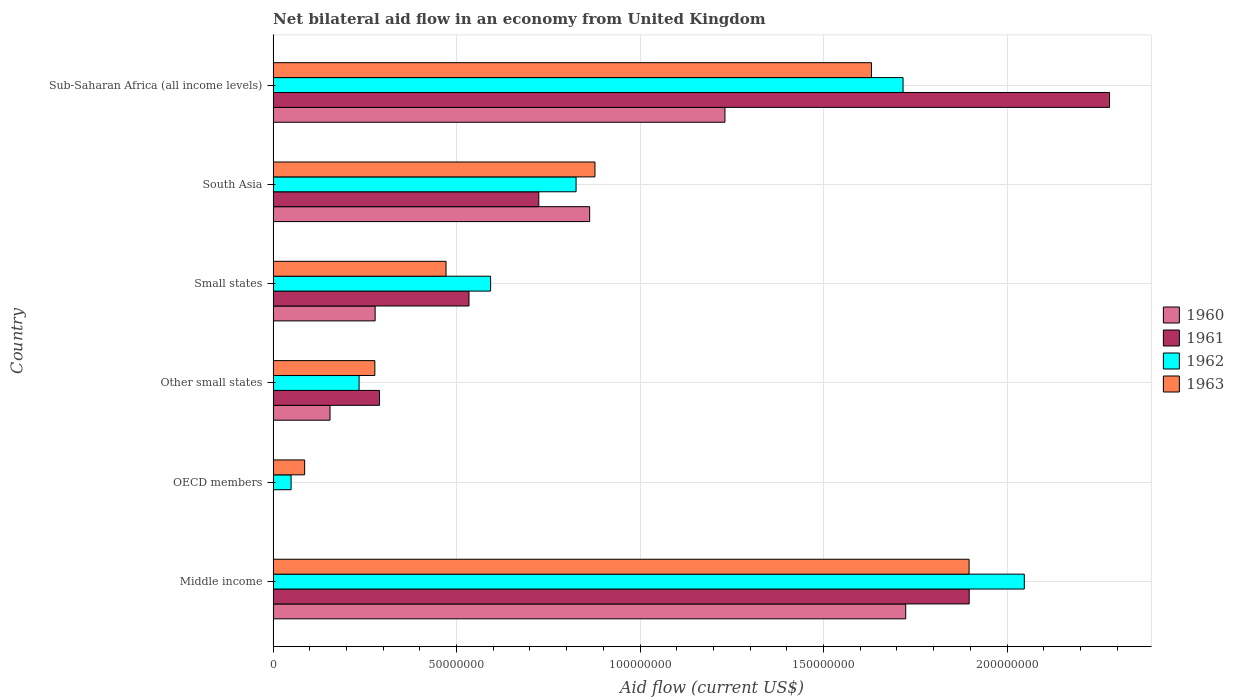How many different coloured bars are there?
Make the answer very short. 4. How many groups of bars are there?
Provide a succinct answer. 6. What is the label of the 3rd group of bars from the top?
Your response must be concise. Small states. What is the net bilateral aid flow in 1963 in Small states?
Provide a succinct answer. 4.71e+07. Across all countries, what is the maximum net bilateral aid flow in 1963?
Offer a very short reply. 1.90e+08. Across all countries, what is the minimum net bilateral aid flow in 1963?
Ensure brevity in your answer.  8.59e+06. In which country was the net bilateral aid flow in 1961 maximum?
Offer a terse response. Sub-Saharan Africa (all income levels). What is the total net bilateral aid flow in 1961 in the graph?
Keep it short and to the point. 5.72e+08. What is the difference between the net bilateral aid flow in 1962 in South Asia and that in Sub-Saharan Africa (all income levels)?
Make the answer very short. -8.91e+07. What is the difference between the net bilateral aid flow in 1963 in South Asia and the net bilateral aid flow in 1961 in Middle income?
Your response must be concise. -1.02e+08. What is the average net bilateral aid flow in 1961 per country?
Your answer should be very brief. 9.54e+07. What is the difference between the net bilateral aid flow in 1961 and net bilateral aid flow in 1960 in Small states?
Keep it short and to the point. 2.56e+07. In how many countries, is the net bilateral aid flow in 1961 greater than 50000000 US$?
Provide a succinct answer. 4. What is the ratio of the net bilateral aid flow in 1962 in South Asia to that in Sub-Saharan Africa (all income levels)?
Offer a terse response. 0.48. What is the difference between the highest and the second highest net bilateral aid flow in 1963?
Your answer should be compact. 2.66e+07. What is the difference between the highest and the lowest net bilateral aid flow in 1961?
Your answer should be compact. 2.28e+08. In how many countries, is the net bilateral aid flow in 1960 greater than the average net bilateral aid flow in 1960 taken over all countries?
Your response must be concise. 3. How many bars are there?
Make the answer very short. 22. Are all the bars in the graph horizontal?
Provide a succinct answer. Yes. What is the difference between two consecutive major ticks on the X-axis?
Your response must be concise. 5.00e+07. Are the values on the major ticks of X-axis written in scientific E-notation?
Keep it short and to the point. No. How many legend labels are there?
Offer a terse response. 4. What is the title of the graph?
Provide a short and direct response. Net bilateral aid flow in an economy from United Kingdom. What is the label or title of the X-axis?
Provide a succinct answer. Aid flow (current US$). What is the label or title of the Y-axis?
Your answer should be very brief. Country. What is the Aid flow (current US$) of 1960 in Middle income?
Make the answer very short. 1.72e+08. What is the Aid flow (current US$) in 1961 in Middle income?
Provide a succinct answer. 1.90e+08. What is the Aid flow (current US$) in 1962 in Middle income?
Make the answer very short. 2.05e+08. What is the Aid flow (current US$) in 1963 in Middle income?
Your answer should be very brief. 1.90e+08. What is the Aid flow (current US$) in 1960 in OECD members?
Offer a terse response. 0. What is the Aid flow (current US$) in 1962 in OECD members?
Make the answer very short. 4.90e+06. What is the Aid flow (current US$) of 1963 in OECD members?
Offer a very short reply. 8.59e+06. What is the Aid flow (current US$) in 1960 in Other small states?
Your answer should be very brief. 1.55e+07. What is the Aid flow (current US$) in 1961 in Other small states?
Give a very brief answer. 2.90e+07. What is the Aid flow (current US$) in 1962 in Other small states?
Ensure brevity in your answer.  2.34e+07. What is the Aid flow (current US$) in 1963 in Other small states?
Your response must be concise. 2.77e+07. What is the Aid flow (current US$) of 1960 in Small states?
Your answer should be compact. 2.78e+07. What is the Aid flow (current US$) of 1961 in Small states?
Provide a succinct answer. 5.34e+07. What is the Aid flow (current US$) in 1962 in Small states?
Offer a terse response. 5.93e+07. What is the Aid flow (current US$) of 1963 in Small states?
Your answer should be compact. 4.71e+07. What is the Aid flow (current US$) in 1960 in South Asia?
Offer a very short reply. 8.63e+07. What is the Aid flow (current US$) in 1961 in South Asia?
Offer a very short reply. 7.24e+07. What is the Aid flow (current US$) of 1962 in South Asia?
Ensure brevity in your answer.  8.26e+07. What is the Aid flow (current US$) of 1963 in South Asia?
Provide a short and direct response. 8.77e+07. What is the Aid flow (current US$) in 1960 in Sub-Saharan Africa (all income levels)?
Offer a terse response. 1.23e+08. What is the Aid flow (current US$) of 1961 in Sub-Saharan Africa (all income levels)?
Your answer should be very brief. 2.28e+08. What is the Aid flow (current US$) in 1962 in Sub-Saharan Africa (all income levels)?
Your response must be concise. 1.72e+08. What is the Aid flow (current US$) of 1963 in Sub-Saharan Africa (all income levels)?
Your response must be concise. 1.63e+08. Across all countries, what is the maximum Aid flow (current US$) in 1960?
Give a very brief answer. 1.72e+08. Across all countries, what is the maximum Aid flow (current US$) of 1961?
Offer a very short reply. 2.28e+08. Across all countries, what is the maximum Aid flow (current US$) of 1962?
Offer a very short reply. 2.05e+08. Across all countries, what is the maximum Aid flow (current US$) in 1963?
Make the answer very short. 1.90e+08. Across all countries, what is the minimum Aid flow (current US$) of 1961?
Ensure brevity in your answer.  0. Across all countries, what is the minimum Aid flow (current US$) of 1962?
Your response must be concise. 4.90e+06. Across all countries, what is the minimum Aid flow (current US$) in 1963?
Provide a short and direct response. 8.59e+06. What is the total Aid flow (current US$) of 1960 in the graph?
Your answer should be very brief. 4.25e+08. What is the total Aid flow (current US$) in 1961 in the graph?
Provide a succinct answer. 5.72e+08. What is the total Aid flow (current US$) of 1962 in the graph?
Provide a short and direct response. 5.47e+08. What is the total Aid flow (current US$) in 1963 in the graph?
Offer a very short reply. 5.24e+08. What is the difference between the Aid flow (current US$) of 1962 in Middle income and that in OECD members?
Your answer should be very brief. 2.00e+08. What is the difference between the Aid flow (current US$) in 1963 in Middle income and that in OECD members?
Make the answer very short. 1.81e+08. What is the difference between the Aid flow (current US$) of 1960 in Middle income and that in Other small states?
Ensure brevity in your answer.  1.57e+08. What is the difference between the Aid flow (current US$) of 1961 in Middle income and that in Other small states?
Offer a very short reply. 1.61e+08. What is the difference between the Aid flow (current US$) in 1962 in Middle income and that in Other small states?
Offer a terse response. 1.81e+08. What is the difference between the Aid flow (current US$) in 1963 in Middle income and that in Other small states?
Provide a short and direct response. 1.62e+08. What is the difference between the Aid flow (current US$) of 1960 in Middle income and that in Small states?
Provide a short and direct response. 1.45e+08. What is the difference between the Aid flow (current US$) of 1961 in Middle income and that in Small states?
Make the answer very short. 1.36e+08. What is the difference between the Aid flow (current US$) of 1962 in Middle income and that in Small states?
Your response must be concise. 1.45e+08. What is the difference between the Aid flow (current US$) in 1963 in Middle income and that in Small states?
Give a very brief answer. 1.43e+08. What is the difference between the Aid flow (current US$) in 1960 in Middle income and that in South Asia?
Offer a very short reply. 8.61e+07. What is the difference between the Aid flow (current US$) of 1961 in Middle income and that in South Asia?
Give a very brief answer. 1.17e+08. What is the difference between the Aid flow (current US$) in 1962 in Middle income and that in South Asia?
Offer a very short reply. 1.22e+08. What is the difference between the Aid flow (current US$) in 1963 in Middle income and that in South Asia?
Your answer should be compact. 1.02e+08. What is the difference between the Aid flow (current US$) of 1960 in Middle income and that in Sub-Saharan Africa (all income levels)?
Make the answer very short. 4.93e+07. What is the difference between the Aid flow (current US$) in 1961 in Middle income and that in Sub-Saharan Africa (all income levels)?
Ensure brevity in your answer.  -3.82e+07. What is the difference between the Aid flow (current US$) in 1962 in Middle income and that in Sub-Saharan Africa (all income levels)?
Provide a short and direct response. 3.30e+07. What is the difference between the Aid flow (current US$) of 1963 in Middle income and that in Sub-Saharan Africa (all income levels)?
Your response must be concise. 2.66e+07. What is the difference between the Aid flow (current US$) in 1962 in OECD members and that in Other small states?
Provide a short and direct response. -1.85e+07. What is the difference between the Aid flow (current US$) in 1963 in OECD members and that in Other small states?
Offer a terse response. -1.91e+07. What is the difference between the Aid flow (current US$) of 1962 in OECD members and that in Small states?
Your response must be concise. -5.44e+07. What is the difference between the Aid flow (current US$) of 1963 in OECD members and that in Small states?
Keep it short and to the point. -3.85e+07. What is the difference between the Aid flow (current US$) in 1962 in OECD members and that in South Asia?
Keep it short and to the point. -7.77e+07. What is the difference between the Aid flow (current US$) of 1963 in OECD members and that in South Asia?
Make the answer very short. -7.91e+07. What is the difference between the Aid flow (current US$) of 1962 in OECD members and that in Sub-Saharan Africa (all income levels)?
Make the answer very short. -1.67e+08. What is the difference between the Aid flow (current US$) in 1963 in OECD members and that in Sub-Saharan Africa (all income levels)?
Your answer should be very brief. -1.54e+08. What is the difference between the Aid flow (current US$) of 1960 in Other small states and that in Small states?
Give a very brief answer. -1.23e+07. What is the difference between the Aid flow (current US$) in 1961 in Other small states and that in Small states?
Your response must be concise. -2.44e+07. What is the difference between the Aid flow (current US$) in 1962 in Other small states and that in Small states?
Give a very brief answer. -3.58e+07. What is the difference between the Aid flow (current US$) of 1963 in Other small states and that in Small states?
Your response must be concise. -1.94e+07. What is the difference between the Aid flow (current US$) of 1960 in Other small states and that in South Asia?
Your answer should be very brief. -7.08e+07. What is the difference between the Aid flow (current US$) of 1961 in Other small states and that in South Asia?
Ensure brevity in your answer.  -4.34e+07. What is the difference between the Aid flow (current US$) of 1962 in Other small states and that in South Asia?
Your answer should be very brief. -5.91e+07. What is the difference between the Aid flow (current US$) of 1963 in Other small states and that in South Asia?
Provide a short and direct response. -6.00e+07. What is the difference between the Aid flow (current US$) in 1960 in Other small states and that in Sub-Saharan Africa (all income levels)?
Your response must be concise. -1.08e+08. What is the difference between the Aid flow (current US$) of 1961 in Other small states and that in Sub-Saharan Africa (all income levels)?
Offer a very short reply. -1.99e+08. What is the difference between the Aid flow (current US$) of 1962 in Other small states and that in Sub-Saharan Africa (all income levels)?
Ensure brevity in your answer.  -1.48e+08. What is the difference between the Aid flow (current US$) in 1963 in Other small states and that in Sub-Saharan Africa (all income levels)?
Your answer should be very brief. -1.35e+08. What is the difference between the Aid flow (current US$) in 1960 in Small states and that in South Asia?
Your answer should be very brief. -5.85e+07. What is the difference between the Aid flow (current US$) in 1961 in Small states and that in South Asia?
Your answer should be very brief. -1.90e+07. What is the difference between the Aid flow (current US$) in 1962 in Small states and that in South Asia?
Keep it short and to the point. -2.33e+07. What is the difference between the Aid flow (current US$) in 1963 in Small states and that in South Asia?
Give a very brief answer. -4.06e+07. What is the difference between the Aid flow (current US$) in 1960 in Small states and that in Sub-Saharan Africa (all income levels)?
Provide a short and direct response. -9.53e+07. What is the difference between the Aid flow (current US$) in 1961 in Small states and that in Sub-Saharan Africa (all income levels)?
Your response must be concise. -1.75e+08. What is the difference between the Aid flow (current US$) in 1962 in Small states and that in Sub-Saharan Africa (all income levels)?
Keep it short and to the point. -1.12e+08. What is the difference between the Aid flow (current US$) in 1963 in Small states and that in Sub-Saharan Africa (all income levels)?
Offer a terse response. -1.16e+08. What is the difference between the Aid flow (current US$) in 1960 in South Asia and that in Sub-Saharan Africa (all income levels)?
Keep it short and to the point. -3.69e+07. What is the difference between the Aid flow (current US$) of 1961 in South Asia and that in Sub-Saharan Africa (all income levels)?
Ensure brevity in your answer.  -1.56e+08. What is the difference between the Aid flow (current US$) of 1962 in South Asia and that in Sub-Saharan Africa (all income levels)?
Your answer should be very brief. -8.91e+07. What is the difference between the Aid flow (current US$) of 1963 in South Asia and that in Sub-Saharan Africa (all income levels)?
Provide a short and direct response. -7.54e+07. What is the difference between the Aid flow (current US$) in 1960 in Middle income and the Aid flow (current US$) in 1962 in OECD members?
Offer a very short reply. 1.68e+08. What is the difference between the Aid flow (current US$) of 1960 in Middle income and the Aid flow (current US$) of 1963 in OECD members?
Keep it short and to the point. 1.64e+08. What is the difference between the Aid flow (current US$) in 1961 in Middle income and the Aid flow (current US$) in 1962 in OECD members?
Ensure brevity in your answer.  1.85e+08. What is the difference between the Aid flow (current US$) of 1961 in Middle income and the Aid flow (current US$) of 1963 in OECD members?
Ensure brevity in your answer.  1.81e+08. What is the difference between the Aid flow (current US$) in 1962 in Middle income and the Aid flow (current US$) in 1963 in OECD members?
Your response must be concise. 1.96e+08. What is the difference between the Aid flow (current US$) of 1960 in Middle income and the Aid flow (current US$) of 1961 in Other small states?
Make the answer very short. 1.43e+08. What is the difference between the Aid flow (current US$) in 1960 in Middle income and the Aid flow (current US$) in 1962 in Other small states?
Give a very brief answer. 1.49e+08. What is the difference between the Aid flow (current US$) of 1960 in Middle income and the Aid flow (current US$) of 1963 in Other small states?
Keep it short and to the point. 1.45e+08. What is the difference between the Aid flow (current US$) of 1961 in Middle income and the Aid flow (current US$) of 1962 in Other small states?
Offer a terse response. 1.66e+08. What is the difference between the Aid flow (current US$) of 1961 in Middle income and the Aid flow (current US$) of 1963 in Other small states?
Your response must be concise. 1.62e+08. What is the difference between the Aid flow (current US$) of 1962 in Middle income and the Aid flow (current US$) of 1963 in Other small states?
Your answer should be very brief. 1.77e+08. What is the difference between the Aid flow (current US$) in 1960 in Middle income and the Aid flow (current US$) in 1961 in Small states?
Give a very brief answer. 1.19e+08. What is the difference between the Aid flow (current US$) of 1960 in Middle income and the Aid flow (current US$) of 1962 in Small states?
Offer a terse response. 1.13e+08. What is the difference between the Aid flow (current US$) of 1960 in Middle income and the Aid flow (current US$) of 1963 in Small states?
Provide a succinct answer. 1.25e+08. What is the difference between the Aid flow (current US$) in 1961 in Middle income and the Aid flow (current US$) in 1962 in Small states?
Offer a terse response. 1.30e+08. What is the difference between the Aid flow (current US$) in 1961 in Middle income and the Aid flow (current US$) in 1963 in Small states?
Keep it short and to the point. 1.43e+08. What is the difference between the Aid flow (current US$) of 1962 in Middle income and the Aid flow (current US$) of 1963 in Small states?
Your answer should be compact. 1.58e+08. What is the difference between the Aid flow (current US$) of 1960 in Middle income and the Aid flow (current US$) of 1962 in South Asia?
Provide a succinct answer. 8.98e+07. What is the difference between the Aid flow (current US$) of 1960 in Middle income and the Aid flow (current US$) of 1963 in South Asia?
Your answer should be very brief. 8.47e+07. What is the difference between the Aid flow (current US$) of 1961 in Middle income and the Aid flow (current US$) of 1962 in South Asia?
Give a very brief answer. 1.07e+08. What is the difference between the Aid flow (current US$) of 1961 in Middle income and the Aid flow (current US$) of 1963 in South Asia?
Offer a terse response. 1.02e+08. What is the difference between the Aid flow (current US$) in 1962 in Middle income and the Aid flow (current US$) in 1963 in South Asia?
Your answer should be compact. 1.17e+08. What is the difference between the Aid flow (current US$) of 1960 in Middle income and the Aid flow (current US$) of 1961 in Sub-Saharan Africa (all income levels)?
Provide a succinct answer. -5.55e+07. What is the difference between the Aid flow (current US$) of 1960 in Middle income and the Aid flow (current US$) of 1962 in Sub-Saharan Africa (all income levels)?
Your answer should be compact. 7.30e+05. What is the difference between the Aid flow (current US$) in 1960 in Middle income and the Aid flow (current US$) in 1963 in Sub-Saharan Africa (all income levels)?
Offer a terse response. 9.34e+06. What is the difference between the Aid flow (current US$) in 1961 in Middle income and the Aid flow (current US$) in 1962 in Sub-Saharan Africa (all income levels)?
Give a very brief answer. 1.80e+07. What is the difference between the Aid flow (current US$) of 1961 in Middle income and the Aid flow (current US$) of 1963 in Sub-Saharan Africa (all income levels)?
Your response must be concise. 2.66e+07. What is the difference between the Aid flow (current US$) of 1962 in Middle income and the Aid flow (current US$) of 1963 in Sub-Saharan Africa (all income levels)?
Your answer should be very brief. 4.16e+07. What is the difference between the Aid flow (current US$) of 1962 in OECD members and the Aid flow (current US$) of 1963 in Other small states?
Provide a short and direct response. -2.28e+07. What is the difference between the Aid flow (current US$) of 1962 in OECD members and the Aid flow (current US$) of 1963 in Small states?
Offer a terse response. -4.22e+07. What is the difference between the Aid flow (current US$) in 1962 in OECD members and the Aid flow (current US$) in 1963 in South Asia?
Give a very brief answer. -8.28e+07. What is the difference between the Aid flow (current US$) in 1962 in OECD members and the Aid flow (current US$) in 1963 in Sub-Saharan Africa (all income levels)?
Give a very brief answer. -1.58e+08. What is the difference between the Aid flow (current US$) of 1960 in Other small states and the Aid flow (current US$) of 1961 in Small states?
Ensure brevity in your answer.  -3.79e+07. What is the difference between the Aid flow (current US$) in 1960 in Other small states and the Aid flow (current US$) in 1962 in Small states?
Offer a terse response. -4.38e+07. What is the difference between the Aid flow (current US$) of 1960 in Other small states and the Aid flow (current US$) of 1963 in Small states?
Your answer should be compact. -3.16e+07. What is the difference between the Aid flow (current US$) in 1961 in Other small states and the Aid flow (current US$) in 1962 in Small states?
Your answer should be very brief. -3.03e+07. What is the difference between the Aid flow (current US$) in 1961 in Other small states and the Aid flow (current US$) in 1963 in Small states?
Your answer should be compact. -1.81e+07. What is the difference between the Aid flow (current US$) in 1962 in Other small states and the Aid flow (current US$) in 1963 in Small states?
Offer a very short reply. -2.37e+07. What is the difference between the Aid flow (current US$) in 1960 in Other small states and the Aid flow (current US$) in 1961 in South Asia?
Your answer should be very brief. -5.69e+07. What is the difference between the Aid flow (current US$) of 1960 in Other small states and the Aid flow (current US$) of 1962 in South Asia?
Offer a very short reply. -6.70e+07. What is the difference between the Aid flow (current US$) of 1960 in Other small states and the Aid flow (current US$) of 1963 in South Asia?
Provide a short and direct response. -7.22e+07. What is the difference between the Aid flow (current US$) of 1961 in Other small states and the Aid flow (current US$) of 1962 in South Asia?
Make the answer very short. -5.36e+07. What is the difference between the Aid flow (current US$) of 1961 in Other small states and the Aid flow (current US$) of 1963 in South Asia?
Provide a succinct answer. -5.87e+07. What is the difference between the Aid flow (current US$) in 1962 in Other small states and the Aid flow (current US$) in 1963 in South Asia?
Ensure brevity in your answer.  -6.43e+07. What is the difference between the Aid flow (current US$) of 1960 in Other small states and the Aid flow (current US$) of 1961 in Sub-Saharan Africa (all income levels)?
Your answer should be very brief. -2.12e+08. What is the difference between the Aid flow (current US$) in 1960 in Other small states and the Aid flow (current US$) in 1962 in Sub-Saharan Africa (all income levels)?
Your answer should be very brief. -1.56e+08. What is the difference between the Aid flow (current US$) in 1960 in Other small states and the Aid flow (current US$) in 1963 in Sub-Saharan Africa (all income levels)?
Ensure brevity in your answer.  -1.48e+08. What is the difference between the Aid flow (current US$) of 1961 in Other small states and the Aid flow (current US$) of 1962 in Sub-Saharan Africa (all income levels)?
Provide a short and direct response. -1.43e+08. What is the difference between the Aid flow (current US$) in 1961 in Other small states and the Aid flow (current US$) in 1963 in Sub-Saharan Africa (all income levels)?
Your response must be concise. -1.34e+08. What is the difference between the Aid flow (current US$) of 1962 in Other small states and the Aid flow (current US$) of 1963 in Sub-Saharan Africa (all income levels)?
Ensure brevity in your answer.  -1.40e+08. What is the difference between the Aid flow (current US$) in 1960 in Small states and the Aid flow (current US$) in 1961 in South Asia?
Provide a short and direct response. -4.46e+07. What is the difference between the Aid flow (current US$) of 1960 in Small states and the Aid flow (current US$) of 1962 in South Asia?
Your answer should be very brief. -5.48e+07. What is the difference between the Aid flow (current US$) in 1960 in Small states and the Aid flow (current US$) in 1963 in South Asia?
Provide a short and direct response. -5.99e+07. What is the difference between the Aid flow (current US$) in 1961 in Small states and the Aid flow (current US$) in 1962 in South Asia?
Make the answer very short. -2.92e+07. What is the difference between the Aid flow (current US$) in 1961 in Small states and the Aid flow (current US$) in 1963 in South Asia?
Ensure brevity in your answer.  -3.43e+07. What is the difference between the Aid flow (current US$) of 1962 in Small states and the Aid flow (current US$) of 1963 in South Asia?
Your answer should be very brief. -2.84e+07. What is the difference between the Aid flow (current US$) in 1960 in Small states and the Aid flow (current US$) in 1961 in Sub-Saharan Africa (all income levels)?
Make the answer very short. -2.00e+08. What is the difference between the Aid flow (current US$) of 1960 in Small states and the Aid flow (current US$) of 1962 in Sub-Saharan Africa (all income levels)?
Offer a very short reply. -1.44e+08. What is the difference between the Aid flow (current US$) of 1960 in Small states and the Aid flow (current US$) of 1963 in Sub-Saharan Africa (all income levels)?
Your answer should be very brief. -1.35e+08. What is the difference between the Aid flow (current US$) of 1961 in Small states and the Aid flow (current US$) of 1962 in Sub-Saharan Africa (all income levels)?
Offer a terse response. -1.18e+08. What is the difference between the Aid flow (current US$) in 1961 in Small states and the Aid flow (current US$) in 1963 in Sub-Saharan Africa (all income levels)?
Your answer should be compact. -1.10e+08. What is the difference between the Aid flow (current US$) of 1962 in Small states and the Aid flow (current US$) of 1963 in Sub-Saharan Africa (all income levels)?
Your response must be concise. -1.04e+08. What is the difference between the Aid flow (current US$) in 1960 in South Asia and the Aid flow (current US$) in 1961 in Sub-Saharan Africa (all income levels)?
Ensure brevity in your answer.  -1.42e+08. What is the difference between the Aid flow (current US$) of 1960 in South Asia and the Aid flow (current US$) of 1962 in Sub-Saharan Africa (all income levels)?
Your response must be concise. -8.54e+07. What is the difference between the Aid flow (current US$) of 1960 in South Asia and the Aid flow (current US$) of 1963 in Sub-Saharan Africa (all income levels)?
Offer a very short reply. -7.68e+07. What is the difference between the Aid flow (current US$) in 1961 in South Asia and the Aid flow (current US$) in 1962 in Sub-Saharan Africa (all income levels)?
Your response must be concise. -9.93e+07. What is the difference between the Aid flow (current US$) in 1961 in South Asia and the Aid flow (current US$) in 1963 in Sub-Saharan Africa (all income levels)?
Offer a terse response. -9.07e+07. What is the difference between the Aid flow (current US$) of 1962 in South Asia and the Aid flow (current US$) of 1963 in Sub-Saharan Africa (all income levels)?
Make the answer very short. -8.05e+07. What is the average Aid flow (current US$) of 1960 per country?
Offer a terse response. 7.08e+07. What is the average Aid flow (current US$) of 1961 per country?
Make the answer very short. 9.54e+07. What is the average Aid flow (current US$) of 1962 per country?
Keep it short and to the point. 9.11e+07. What is the average Aid flow (current US$) of 1963 per country?
Ensure brevity in your answer.  8.73e+07. What is the difference between the Aid flow (current US$) of 1960 and Aid flow (current US$) of 1961 in Middle income?
Keep it short and to the point. -1.73e+07. What is the difference between the Aid flow (current US$) of 1960 and Aid flow (current US$) of 1962 in Middle income?
Ensure brevity in your answer.  -3.23e+07. What is the difference between the Aid flow (current US$) in 1960 and Aid flow (current US$) in 1963 in Middle income?
Make the answer very short. -1.73e+07. What is the difference between the Aid flow (current US$) in 1961 and Aid flow (current US$) in 1962 in Middle income?
Your response must be concise. -1.50e+07. What is the difference between the Aid flow (current US$) in 1962 and Aid flow (current US$) in 1963 in Middle income?
Give a very brief answer. 1.50e+07. What is the difference between the Aid flow (current US$) of 1962 and Aid flow (current US$) of 1963 in OECD members?
Your answer should be very brief. -3.69e+06. What is the difference between the Aid flow (current US$) in 1960 and Aid flow (current US$) in 1961 in Other small states?
Provide a short and direct response. -1.35e+07. What is the difference between the Aid flow (current US$) of 1960 and Aid flow (current US$) of 1962 in Other small states?
Your answer should be compact. -7.92e+06. What is the difference between the Aid flow (current US$) in 1960 and Aid flow (current US$) in 1963 in Other small states?
Offer a very short reply. -1.22e+07. What is the difference between the Aid flow (current US$) of 1961 and Aid flow (current US$) of 1962 in Other small states?
Your answer should be very brief. 5.56e+06. What is the difference between the Aid flow (current US$) in 1961 and Aid flow (current US$) in 1963 in Other small states?
Offer a terse response. 1.27e+06. What is the difference between the Aid flow (current US$) in 1962 and Aid flow (current US$) in 1963 in Other small states?
Your answer should be compact. -4.29e+06. What is the difference between the Aid flow (current US$) in 1960 and Aid flow (current US$) in 1961 in Small states?
Your response must be concise. -2.56e+07. What is the difference between the Aid flow (current US$) of 1960 and Aid flow (current US$) of 1962 in Small states?
Your response must be concise. -3.15e+07. What is the difference between the Aid flow (current US$) in 1960 and Aid flow (current US$) in 1963 in Small states?
Your answer should be compact. -1.93e+07. What is the difference between the Aid flow (current US$) of 1961 and Aid flow (current US$) of 1962 in Small states?
Your answer should be compact. -5.89e+06. What is the difference between the Aid flow (current US$) of 1961 and Aid flow (current US$) of 1963 in Small states?
Your answer should be very brief. 6.26e+06. What is the difference between the Aid flow (current US$) in 1962 and Aid flow (current US$) in 1963 in Small states?
Keep it short and to the point. 1.22e+07. What is the difference between the Aid flow (current US$) of 1960 and Aid flow (current US$) of 1961 in South Asia?
Offer a terse response. 1.39e+07. What is the difference between the Aid flow (current US$) of 1960 and Aid flow (current US$) of 1962 in South Asia?
Your answer should be compact. 3.70e+06. What is the difference between the Aid flow (current US$) of 1960 and Aid flow (current US$) of 1963 in South Asia?
Give a very brief answer. -1.45e+06. What is the difference between the Aid flow (current US$) in 1961 and Aid flow (current US$) in 1962 in South Asia?
Give a very brief answer. -1.02e+07. What is the difference between the Aid flow (current US$) in 1961 and Aid flow (current US$) in 1963 in South Asia?
Offer a very short reply. -1.53e+07. What is the difference between the Aid flow (current US$) of 1962 and Aid flow (current US$) of 1963 in South Asia?
Offer a terse response. -5.15e+06. What is the difference between the Aid flow (current US$) in 1960 and Aid flow (current US$) in 1961 in Sub-Saharan Africa (all income levels)?
Your answer should be very brief. -1.05e+08. What is the difference between the Aid flow (current US$) of 1960 and Aid flow (current US$) of 1962 in Sub-Saharan Africa (all income levels)?
Ensure brevity in your answer.  -4.85e+07. What is the difference between the Aid flow (current US$) of 1960 and Aid flow (current US$) of 1963 in Sub-Saharan Africa (all income levels)?
Your response must be concise. -3.99e+07. What is the difference between the Aid flow (current US$) of 1961 and Aid flow (current US$) of 1962 in Sub-Saharan Africa (all income levels)?
Make the answer very short. 5.63e+07. What is the difference between the Aid flow (current US$) of 1961 and Aid flow (current US$) of 1963 in Sub-Saharan Africa (all income levels)?
Offer a terse response. 6.49e+07. What is the difference between the Aid flow (current US$) in 1962 and Aid flow (current US$) in 1963 in Sub-Saharan Africa (all income levels)?
Your answer should be very brief. 8.61e+06. What is the ratio of the Aid flow (current US$) of 1962 in Middle income to that in OECD members?
Keep it short and to the point. 41.78. What is the ratio of the Aid flow (current US$) of 1963 in Middle income to that in OECD members?
Your answer should be compact. 22.08. What is the ratio of the Aid flow (current US$) of 1960 in Middle income to that in Other small states?
Provide a short and direct response. 11.12. What is the ratio of the Aid flow (current US$) of 1961 in Middle income to that in Other small states?
Keep it short and to the point. 6.54. What is the ratio of the Aid flow (current US$) of 1962 in Middle income to that in Other small states?
Make the answer very short. 8.74. What is the ratio of the Aid flow (current US$) of 1963 in Middle income to that in Other small states?
Give a very brief answer. 6.84. What is the ratio of the Aid flow (current US$) in 1960 in Middle income to that in Small states?
Ensure brevity in your answer.  6.2. What is the ratio of the Aid flow (current US$) of 1961 in Middle income to that in Small states?
Provide a succinct answer. 3.55. What is the ratio of the Aid flow (current US$) of 1962 in Middle income to that in Small states?
Offer a terse response. 3.45. What is the ratio of the Aid flow (current US$) of 1963 in Middle income to that in Small states?
Ensure brevity in your answer.  4.03. What is the ratio of the Aid flow (current US$) in 1960 in Middle income to that in South Asia?
Your response must be concise. 2. What is the ratio of the Aid flow (current US$) in 1961 in Middle income to that in South Asia?
Ensure brevity in your answer.  2.62. What is the ratio of the Aid flow (current US$) in 1962 in Middle income to that in South Asia?
Make the answer very short. 2.48. What is the ratio of the Aid flow (current US$) in 1963 in Middle income to that in South Asia?
Provide a succinct answer. 2.16. What is the ratio of the Aid flow (current US$) in 1960 in Middle income to that in Sub-Saharan Africa (all income levels)?
Your response must be concise. 1.4. What is the ratio of the Aid flow (current US$) of 1961 in Middle income to that in Sub-Saharan Africa (all income levels)?
Provide a short and direct response. 0.83. What is the ratio of the Aid flow (current US$) of 1962 in Middle income to that in Sub-Saharan Africa (all income levels)?
Offer a terse response. 1.19. What is the ratio of the Aid flow (current US$) of 1963 in Middle income to that in Sub-Saharan Africa (all income levels)?
Provide a succinct answer. 1.16. What is the ratio of the Aid flow (current US$) of 1962 in OECD members to that in Other small states?
Give a very brief answer. 0.21. What is the ratio of the Aid flow (current US$) in 1963 in OECD members to that in Other small states?
Provide a succinct answer. 0.31. What is the ratio of the Aid flow (current US$) of 1962 in OECD members to that in Small states?
Give a very brief answer. 0.08. What is the ratio of the Aid flow (current US$) in 1963 in OECD members to that in Small states?
Ensure brevity in your answer.  0.18. What is the ratio of the Aid flow (current US$) in 1962 in OECD members to that in South Asia?
Your answer should be compact. 0.06. What is the ratio of the Aid flow (current US$) of 1963 in OECD members to that in South Asia?
Provide a short and direct response. 0.1. What is the ratio of the Aid flow (current US$) in 1962 in OECD members to that in Sub-Saharan Africa (all income levels)?
Ensure brevity in your answer.  0.03. What is the ratio of the Aid flow (current US$) in 1963 in OECD members to that in Sub-Saharan Africa (all income levels)?
Your answer should be very brief. 0.05. What is the ratio of the Aid flow (current US$) in 1960 in Other small states to that in Small states?
Your response must be concise. 0.56. What is the ratio of the Aid flow (current US$) in 1961 in Other small states to that in Small states?
Ensure brevity in your answer.  0.54. What is the ratio of the Aid flow (current US$) of 1962 in Other small states to that in Small states?
Your answer should be very brief. 0.4. What is the ratio of the Aid flow (current US$) in 1963 in Other small states to that in Small states?
Your answer should be very brief. 0.59. What is the ratio of the Aid flow (current US$) of 1960 in Other small states to that in South Asia?
Provide a succinct answer. 0.18. What is the ratio of the Aid flow (current US$) in 1961 in Other small states to that in South Asia?
Offer a very short reply. 0.4. What is the ratio of the Aid flow (current US$) in 1962 in Other small states to that in South Asia?
Provide a short and direct response. 0.28. What is the ratio of the Aid flow (current US$) in 1963 in Other small states to that in South Asia?
Keep it short and to the point. 0.32. What is the ratio of the Aid flow (current US$) in 1960 in Other small states to that in Sub-Saharan Africa (all income levels)?
Provide a succinct answer. 0.13. What is the ratio of the Aid flow (current US$) of 1961 in Other small states to that in Sub-Saharan Africa (all income levels)?
Your answer should be very brief. 0.13. What is the ratio of the Aid flow (current US$) in 1962 in Other small states to that in Sub-Saharan Africa (all income levels)?
Ensure brevity in your answer.  0.14. What is the ratio of the Aid flow (current US$) of 1963 in Other small states to that in Sub-Saharan Africa (all income levels)?
Provide a succinct answer. 0.17. What is the ratio of the Aid flow (current US$) of 1960 in Small states to that in South Asia?
Your answer should be compact. 0.32. What is the ratio of the Aid flow (current US$) in 1961 in Small states to that in South Asia?
Offer a terse response. 0.74. What is the ratio of the Aid flow (current US$) of 1962 in Small states to that in South Asia?
Give a very brief answer. 0.72. What is the ratio of the Aid flow (current US$) in 1963 in Small states to that in South Asia?
Ensure brevity in your answer.  0.54. What is the ratio of the Aid flow (current US$) of 1960 in Small states to that in Sub-Saharan Africa (all income levels)?
Give a very brief answer. 0.23. What is the ratio of the Aid flow (current US$) in 1961 in Small states to that in Sub-Saharan Africa (all income levels)?
Offer a very short reply. 0.23. What is the ratio of the Aid flow (current US$) of 1962 in Small states to that in Sub-Saharan Africa (all income levels)?
Keep it short and to the point. 0.35. What is the ratio of the Aid flow (current US$) of 1963 in Small states to that in Sub-Saharan Africa (all income levels)?
Offer a terse response. 0.29. What is the ratio of the Aid flow (current US$) of 1960 in South Asia to that in Sub-Saharan Africa (all income levels)?
Keep it short and to the point. 0.7. What is the ratio of the Aid flow (current US$) of 1961 in South Asia to that in Sub-Saharan Africa (all income levels)?
Your answer should be compact. 0.32. What is the ratio of the Aid flow (current US$) of 1962 in South Asia to that in Sub-Saharan Africa (all income levels)?
Ensure brevity in your answer.  0.48. What is the ratio of the Aid flow (current US$) of 1963 in South Asia to that in Sub-Saharan Africa (all income levels)?
Keep it short and to the point. 0.54. What is the difference between the highest and the second highest Aid flow (current US$) in 1960?
Your answer should be very brief. 4.93e+07. What is the difference between the highest and the second highest Aid flow (current US$) of 1961?
Your answer should be very brief. 3.82e+07. What is the difference between the highest and the second highest Aid flow (current US$) in 1962?
Offer a very short reply. 3.30e+07. What is the difference between the highest and the second highest Aid flow (current US$) in 1963?
Offer a terse response. 2.66e+07. What is the difference between the highest and the lowest Aid flow (current US$) in 1960?
Offer a very short reply. 1.72e+08. What is the difference between the highest and the lowest Aid flow (current US$) in 1961?
Your answer should be very brief. 2.28e+08. What is the difference between the highest and the lowest Aid flow (current US$) of 1962?
Make the answer very short. 2.00e+08. What is the difference between the highest and the lowest Aid flow (current US$) of 1963?
Offer a very short reply. 1.81e+08. 